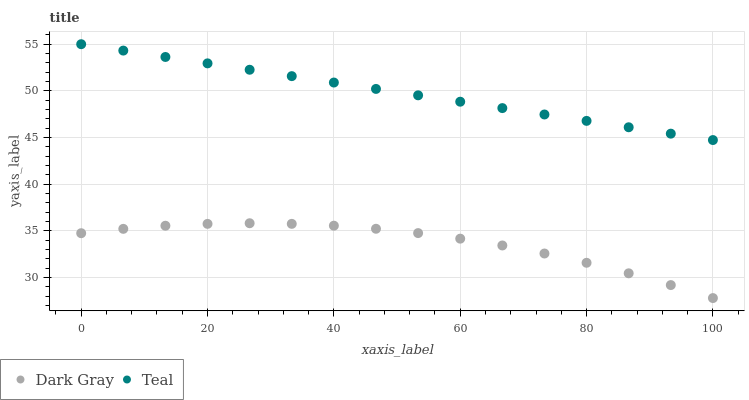Does Dark Gray have the minimum area under the curve?
Answer yes or no. Yes. Does Teal have the maximum area under the curve?
Answer yes or no. Yes. Does Teal have the minimum area under the curve?
Answer yes or no. No. Is Teal the smoothest?
Answer yes or no. Yes. Is Dark Gray the roughest?
Answer yes or no. Yes. Is Teal the roughest?
Answer yes or no. No. Does Dark Gray have the lowest value?
Answer yes or no. Yes. Does Teal have the lowest value?
Answer yes or no. No. Does Teal have the highest value?
Answer yes or no. Yes. Is Dark Gray less than Teal?
Answer yes or no. Yes. Is Teal greater than Dark Gray?
Answer yes or no. Yes. Does Dark Gray intersect Teal?
Answer yes or no. No. 